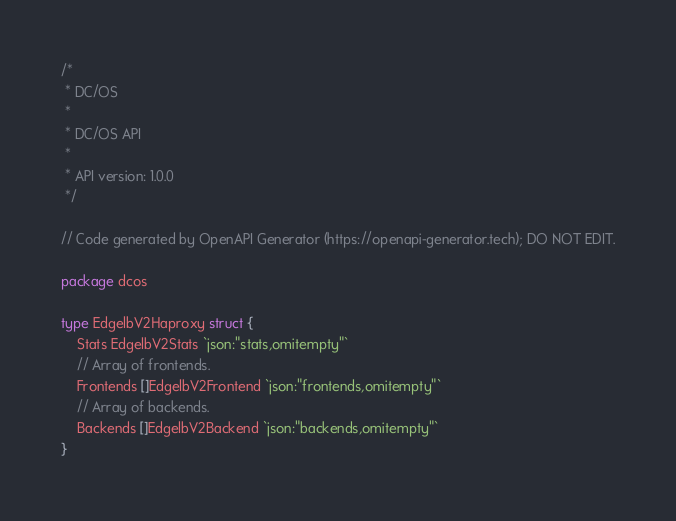Convert code to text. <code><loc_0><loc_0><loc_500><loc_500><_Go_>/*
 * DC/OS
 *
 * DC/OS API
 *
 * API version: 1.0.0
 */

// Code generated by OpenAPI Generator (https://openapi-generator.tech); DO NOT EDIT.

package dcos

type EdgelbV2Haproxy struct {
	Stats EdgelbV2Stats `json:"stats,omitempty"`
	// Array of frontends.
	Frontends []EdgelbV2Frontend `json:"frontends,omitempty"`
	// Array of backends.
	Backends []EdgelbV2Backend `json:"backends,omitempty"`
}
</code> 